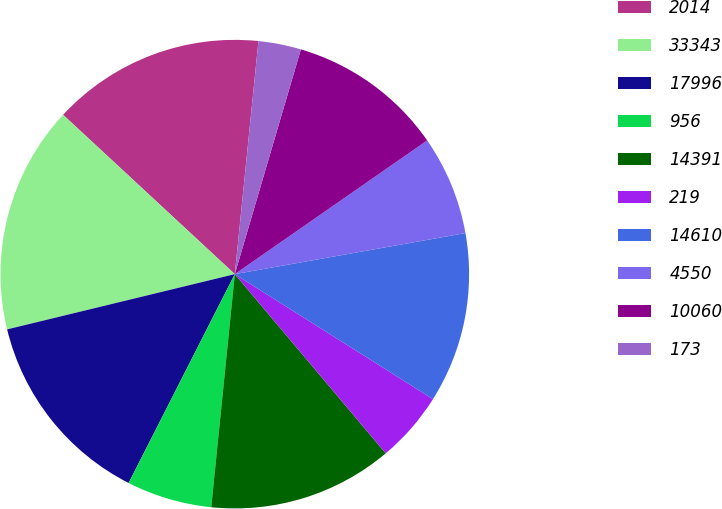<chart> <loc_0><loc_0><loc_500><loc_500><pie_chart><fcel>2014<fcel>33343<fcel>17996<fcel>956<fcel>14391<fcel>219<fcel>14610<fcel>4550<fcel>10060<fcel>173<nl><fcel>14.7%<fcel>15.69%<fcel>13.72%<fcel>5.88%<fcel>12.74%<fcel>4.9%<fcel>11.76%<fcel>6.86%<fcel>10.78%<fcel>2.94%<nl></chart> 